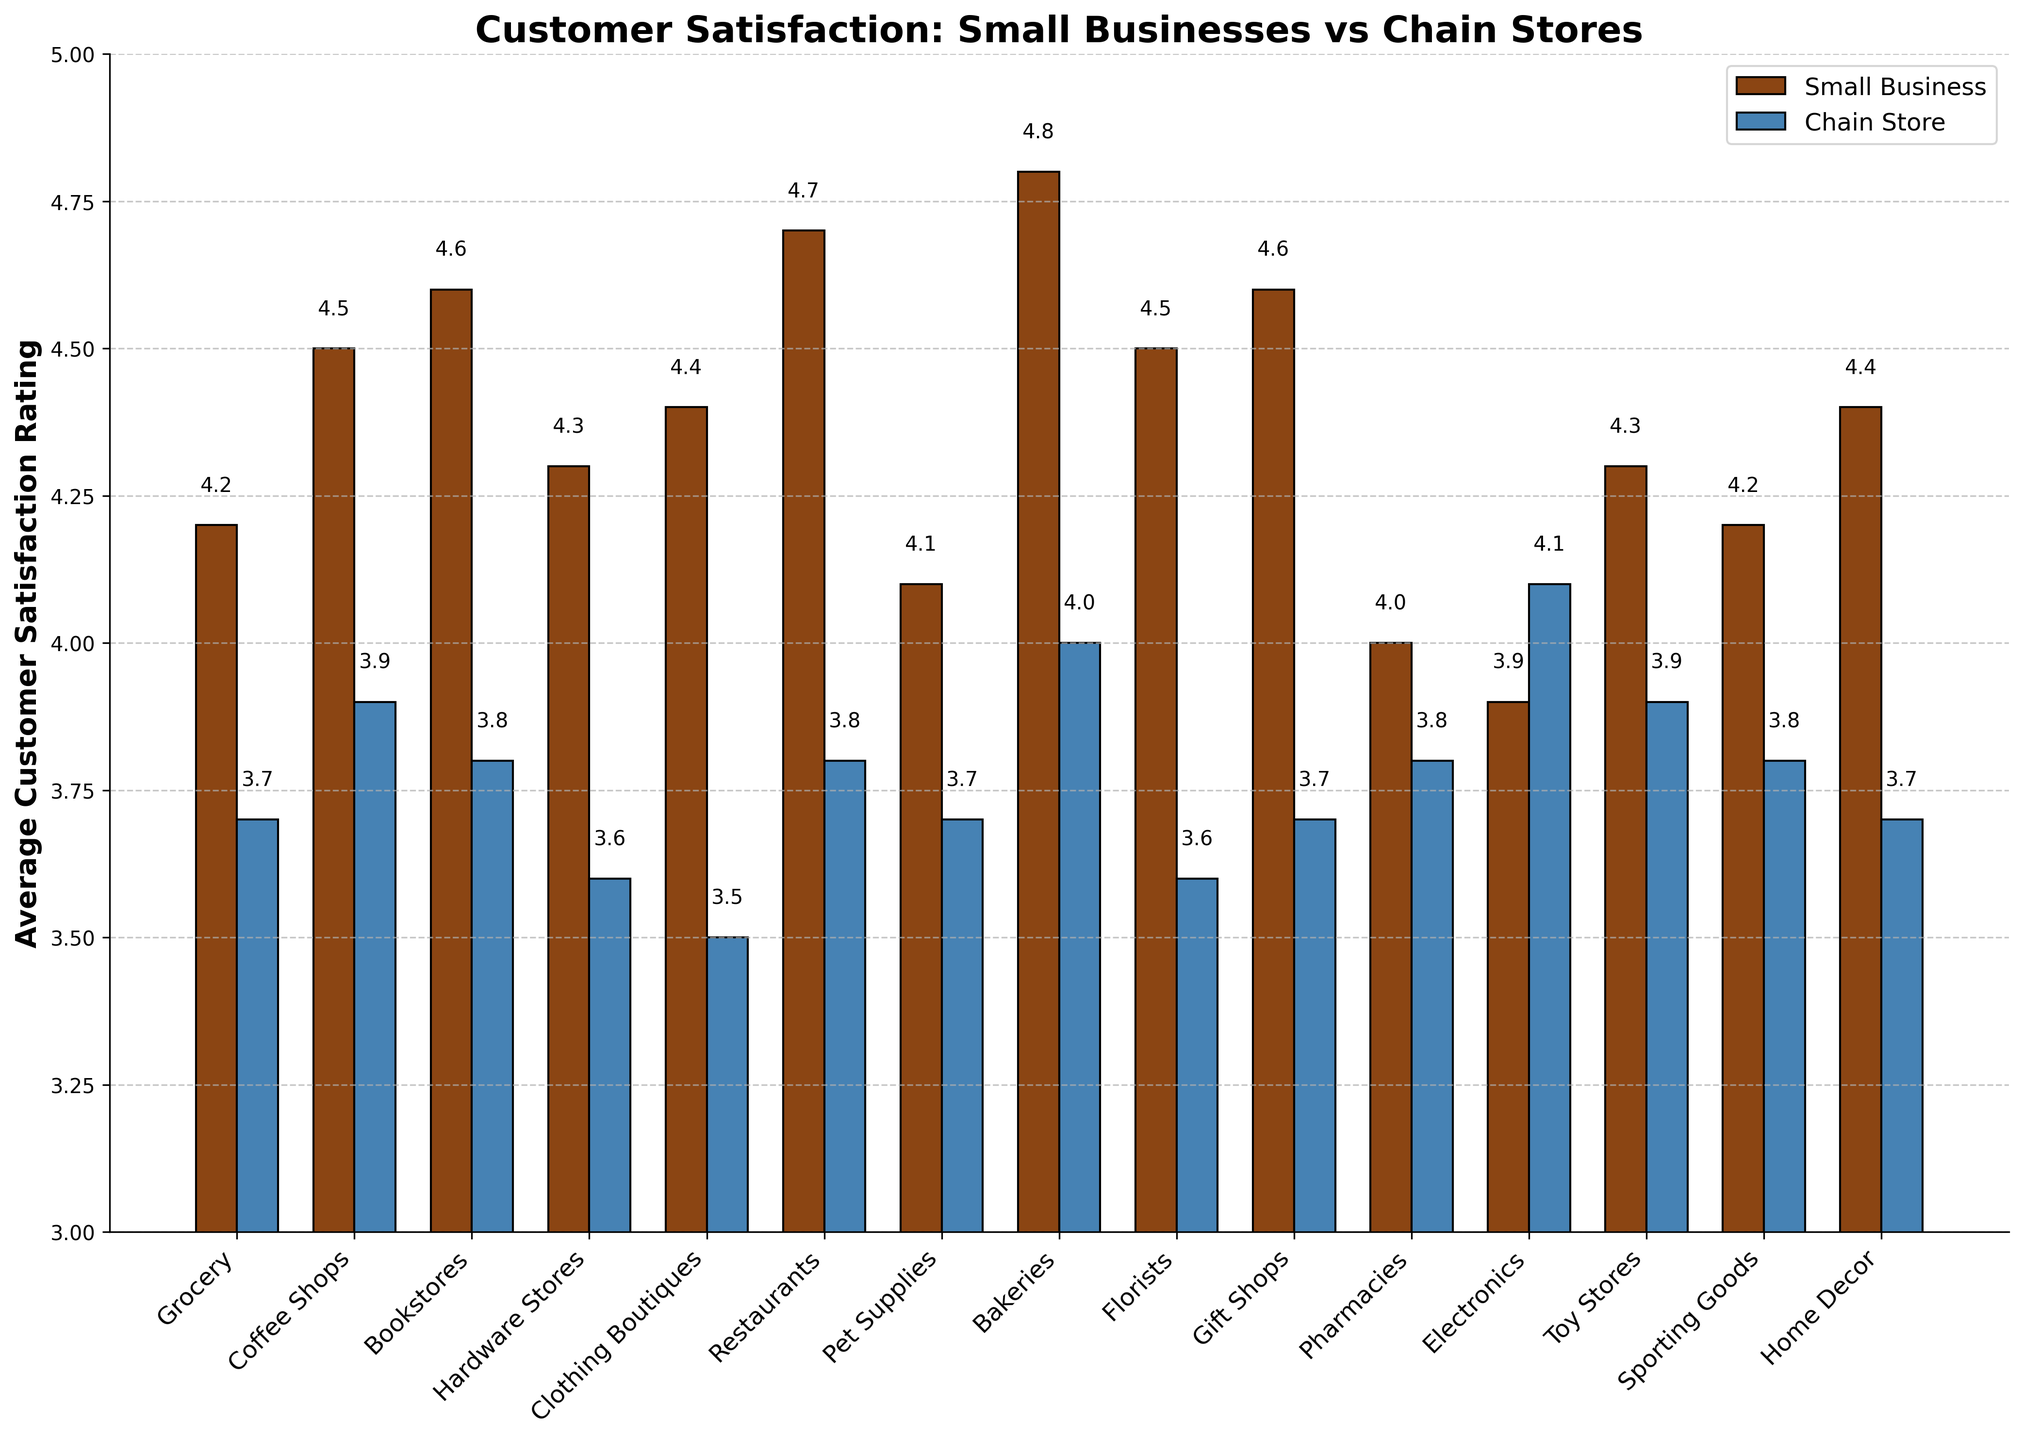Which sector has the highest customer satisfaction rating for small businesses? By looking at the height of the bars for small businesses, determine which sector has the highest value. The sector with the highest bar is the one with the highest rating.
Answer: Bakeries What is the difference in customer satisfaction ratings between small businesses and chain stores for hardware stores? Identify the bars for hardware stores in both small businesses and chain stores, then subtract the chain store rating from the small business rating (4.3 - 3.6).
Answer: 0.7 How many sectors have higher customer satisfaction ratings for small businesses compared to chain stores? For each sector, compare the bar heights of small businesses and chain stores. Count the number of sectors where the small business bar is taller.
Answer: 14 Which sector has the smallest difference in customer satisfaction ratings between small businesses and chain stores? Calculate the absolute difference between the small business and chain store ratings for each sector, then identify the smallest difference. The sectors to calculate are: Grocery (0.5), Coffee Shops (0.6), Bookstores (0.8), Hardware Stores (0.7), Clothing Boutiques (0.9), Restaurants (0.9), Pet Supplies (0.4), Bakeries (0.8), Florists (0.9), Gift Shops (0.9), Pharmacies (0.2), Electronics (0.2), Toy Stores (0.4), Sporting Goods (0.4), Home Decor (0.7). The smallest difference is in Pharmacies and Electronics.
Answer: Pharmacies and Electronics On average, how much higher is the customer satisfaction rating for small businesses compared to chain stores across all sectors? Sum the differences in ratings for small businesses and chain stores across all sectors, then divide by the number of sectors. The differences are: 0.5, 0.6, 0.8, 0.7, 0.9, 0.9, 0.4, 0.8, 0.9, 0.9, 0.2, -0.2, 0.4, 0.4, 0.7. The sum is 9.3, and there are 15 sectors. So, 9.3 / 15 = 0.62
Answer: 0.62 Which two sectors have customer satisfaction ratings for small businesses equal to 4.5? Look for sectors where the small business bar reaches 4.5. Identify these sectors by name from the x-axis labels.
Answer: Coffee Shops and Florists 